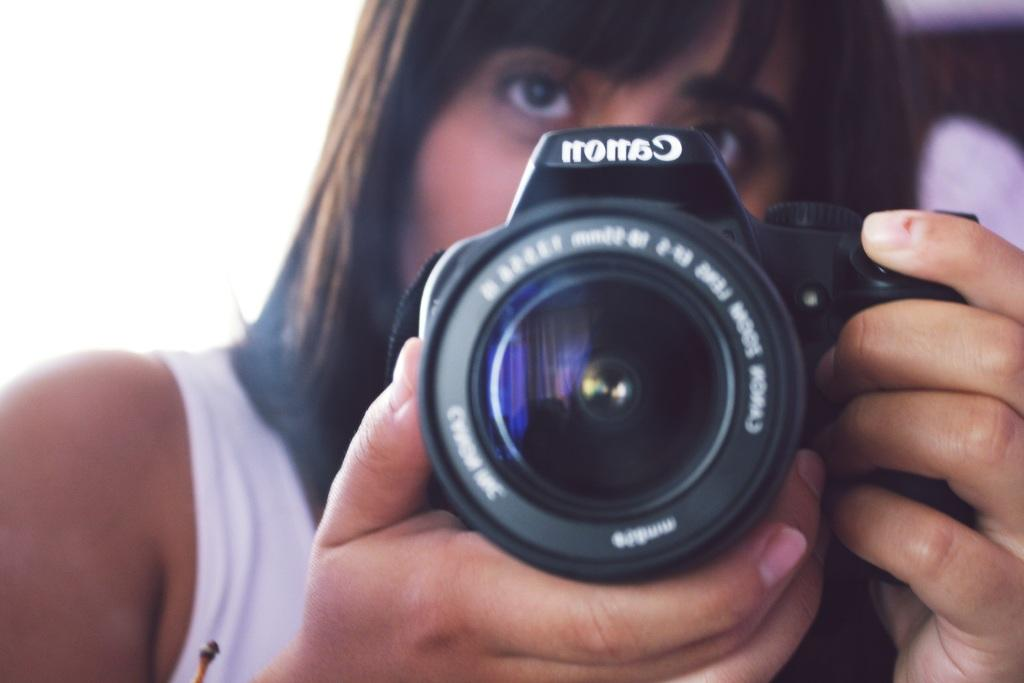Who or what is the main subject of the image? There is a person in the image. What is the person holding in the image? The person is holding a camera. What can be seen on the left side of the image? There is a white background on the left side of the image. What type of committee can be seen in the image? There is no committee present in the image; it features a person holding a camera. What dish is the cook preparing in the image? There is no cook or dish preparation visible in the image. 